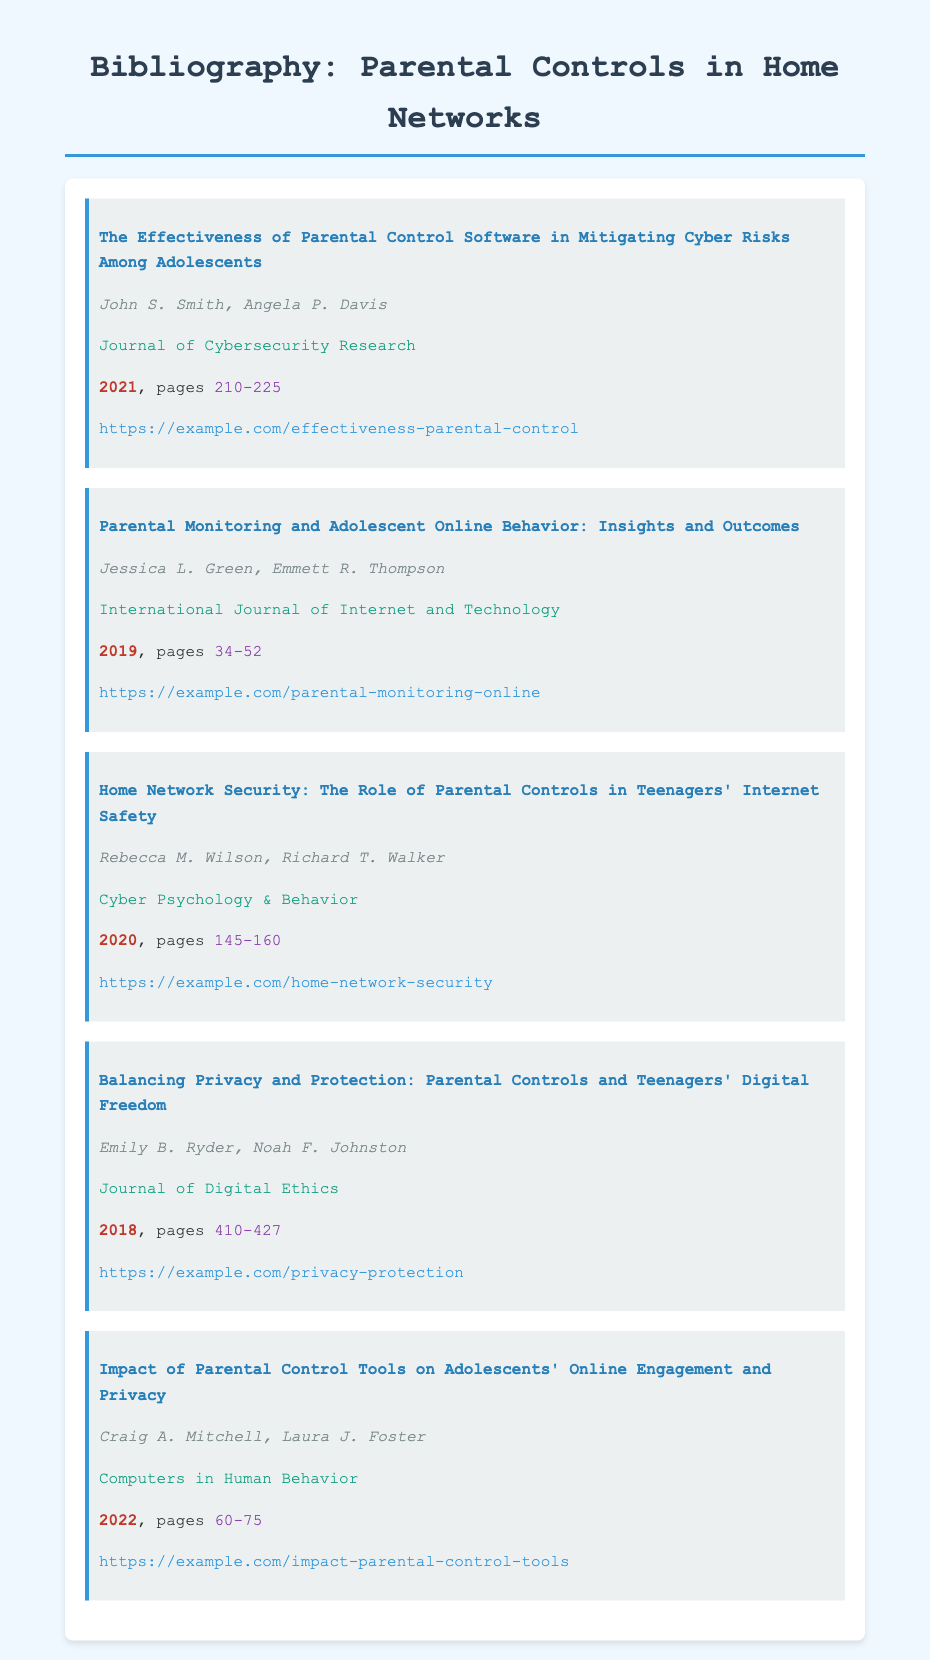What is the title of the first article? The title of the first article is provided in the bibliography entry, which is "The Effectiveness of Parental Control Software in Mitigating Cyber Risks Among Adolescents."
Answer: The Effectiveness of Parental Control Software in Mitigating Cyber Risks Among Adolescents Who are the authors of the third article? The authors of the third article can be found in the entry, which lists "Rebecca M. Wilson, Richard T. Walker."
Answer: Rebecca M. Wilson, Richard T. Walker What year was the article on online behavior published? The publication year for the article titled "Parental Monitoring and Adolescent Online Behavior: Insights and Outcomes" is mentioned in the entry as 2019.
Answer: 2019 How many pages does the last article cover? The number of pages for the last article titled "Impact of Parental Control Tools on Adolescents' Online Engagement and Privacy" is indicated as 60-75.
Answer: 60-75 Which journal published the article discussing balancing privacy and protection? The journal that published the article titled "Balancing Privacy and Protection: Parental Controls and Teenagers' Digital Freedom" is noted in the entry as "Journal of Digital Ethics."
Answer: Journal of Digital Ethics What is the URL for the second article? The URL for the second article providing access to "Parental Monitoring and Adolescent Online Behavior: Insights and Outcomes" can be found in the bibliography entry as "https://example.com/parental-monitoring-online."
Answer: https://example.com/parental-monitoring-online Which article has '2022' as its publication year? The article with '2022' as its publication year is given in the entry titled "Impact of Parental Control Tools on Adolescents' Online Engagement and Privacy."
Answer: Impact of Parental Control Tools on Adolescents' Online Engagement and Privacy How many articles are listed in this bibliography? To find the total number of articles, count the entries in the bibliography, which is 5.
Answer: 5 What is the focus of the third article? The focus of the third article is indicated by its title: "Home Network Security: The Role of Parental Controls in Teenagers' Internet Safety."
Answer: Home Network Security: The Role of Parental Controls in Teenagers' Internet Safety 